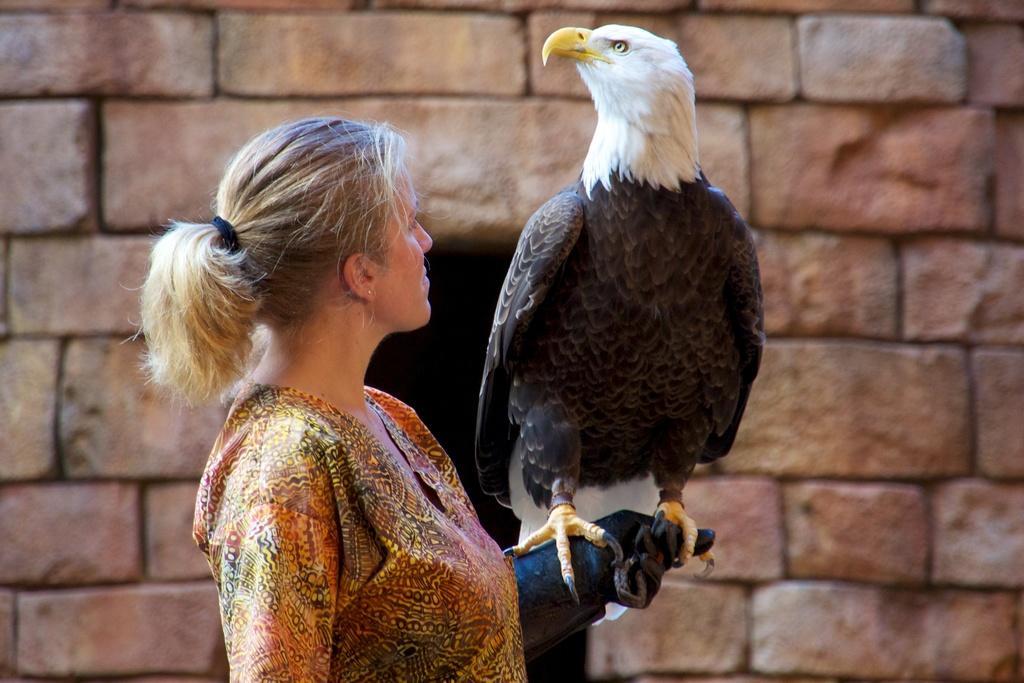How would you summarize this image in a sentence or two? There is a woman standing and holding a leg of a bird which is in white and black color combination and is standing on the hand the woman. In the background, there is a stone's wall. 